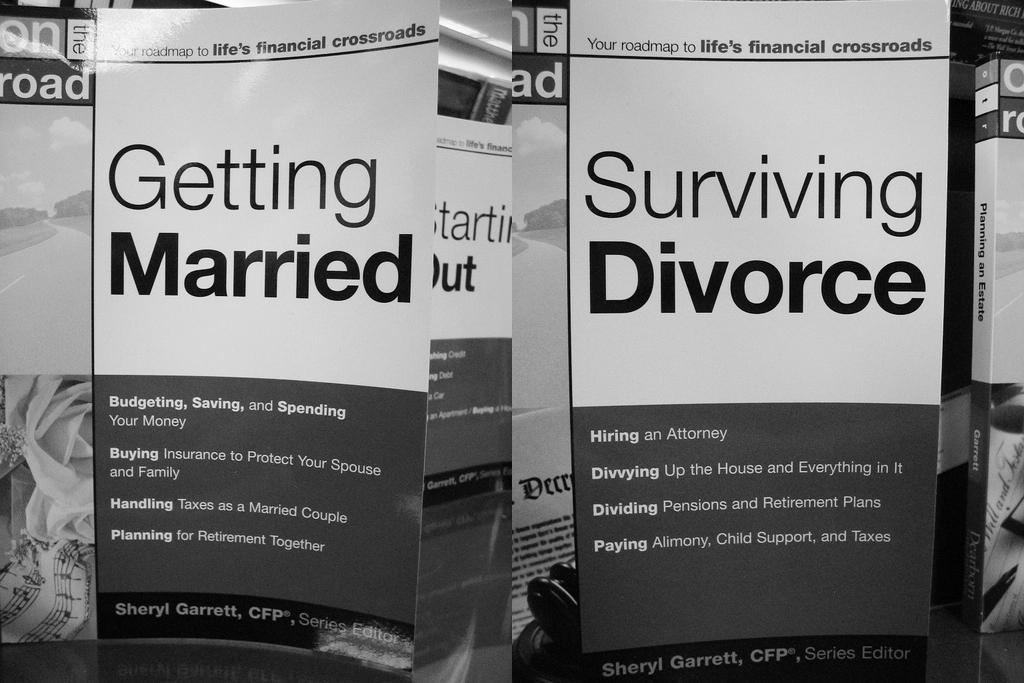<image>
Create a compact narrative representing the image presented. Two posters, on of which is called Getting Married and the other is Surviving Divorce. 